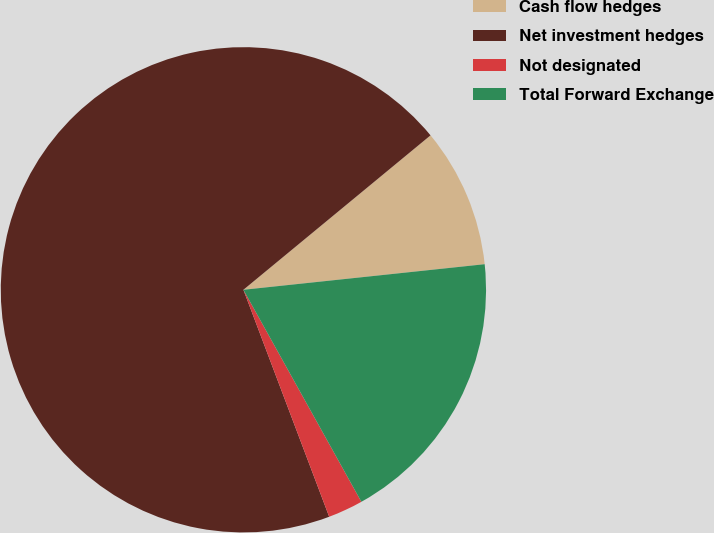Convert chart to OTSL. <chart><loc_0><loc_0><loc_500><loc_500><pie_chart><fcel>Cash flow hedges<fcel>Net investment hedges<fcel>Not designated<fcel>Total Forward Exchange<nl><fcel>9.3%<fcel>69.77%<fcel>2.33%<fcel>18.6%<nl></chart> 